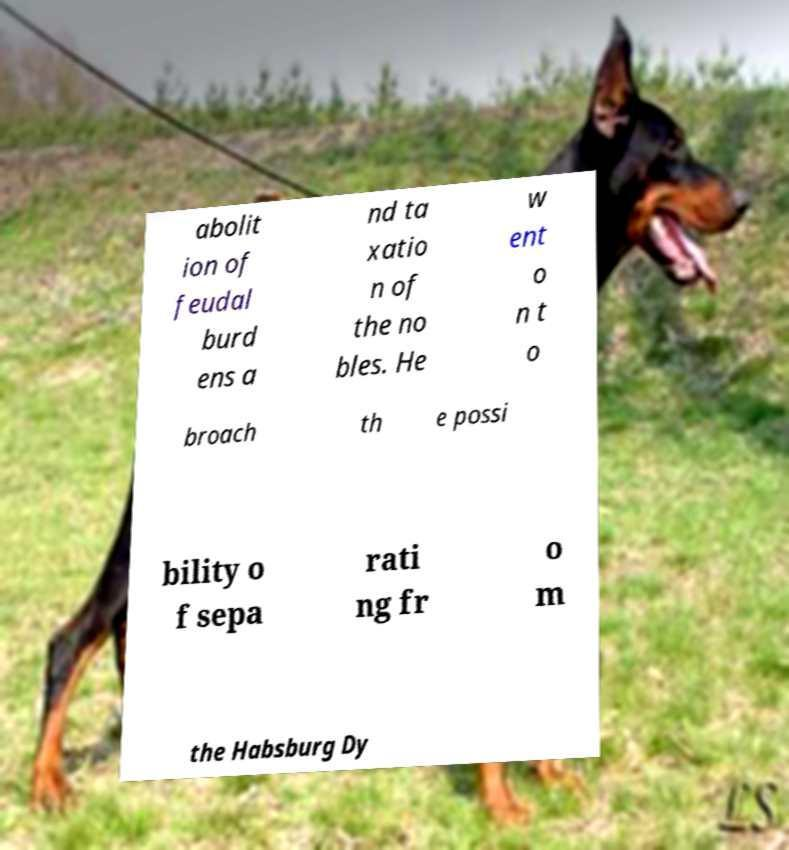Can you accurately transcribe the text from the provided image for me? abolit ion of feudal burd ens a nd ta xatio n of the no bles. He w ent o n t o broach th e possi bility o f sepa rati ng fr o m the Habsburg Dy 